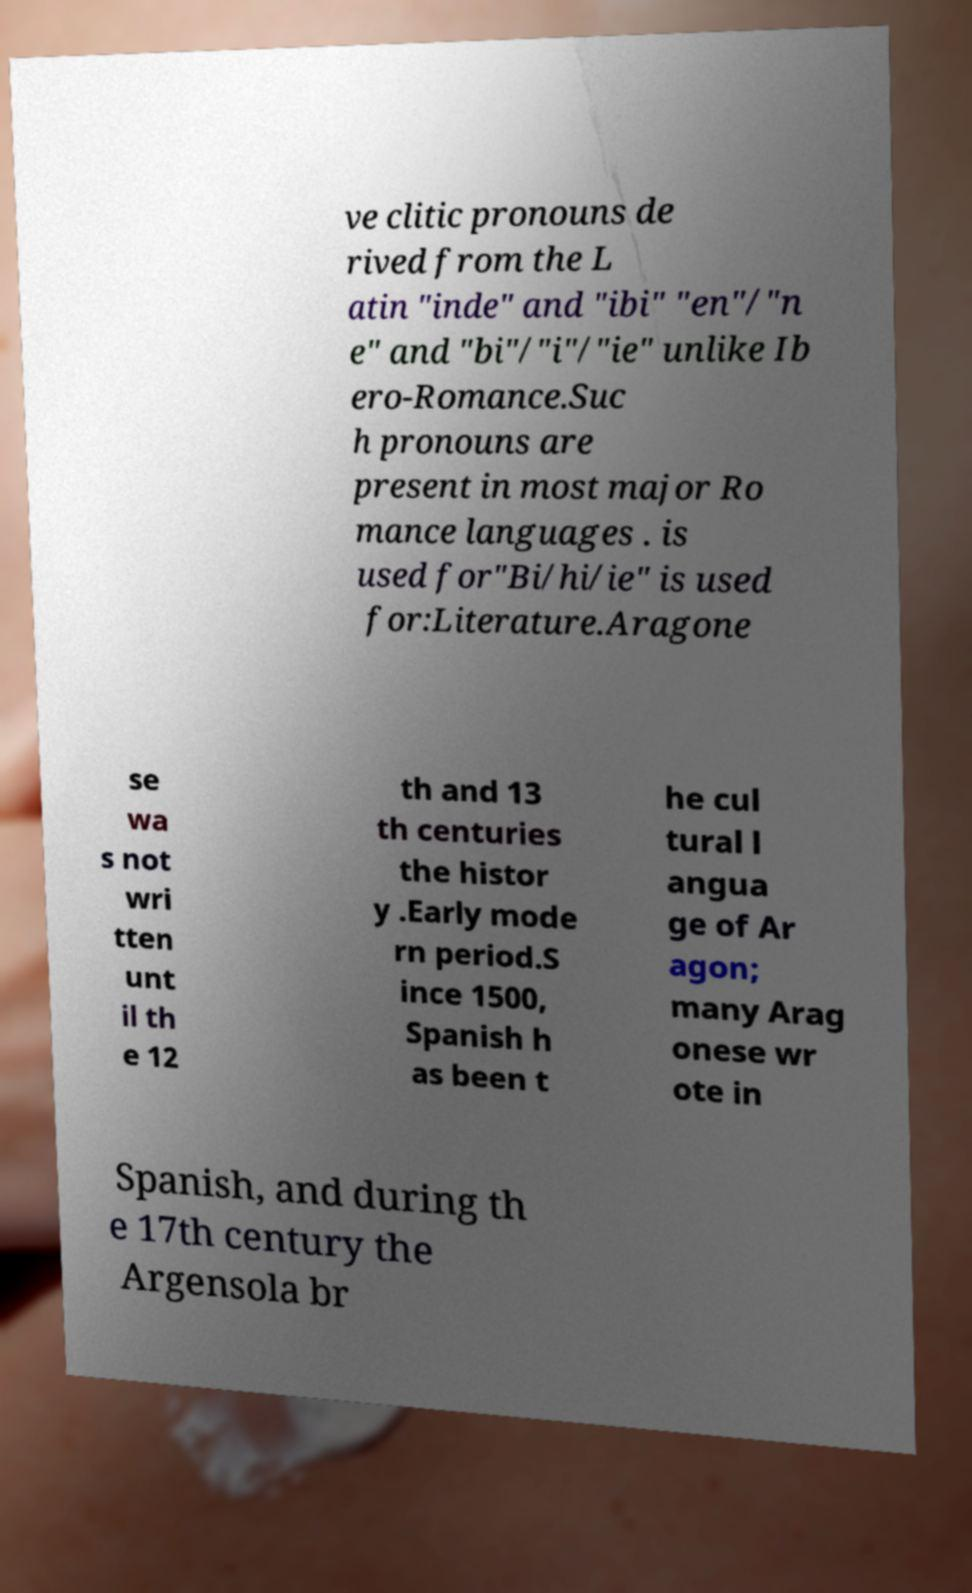Please read and relay the text visible in this image. What does it say? ve clitic pronouns de rived from the L atin "inde" and "ibi" "en"/"n e" and "bi"/"i"/"ie" unlike Ib ero-Romance.Suc h pronouns are present in most major Ro mance languages . is used for"Bi/hi/ie" is used for:Literature.Aragone se wa s not wri tten unt il th e 12 th and 13 th centuries the histor y .Early mode rn period.S ince 1500, Spanish h as been t he cul tural l angua ge of Ar agon; many Arag onese wr ote in Spanish, and during th e 17th century the Argensola br 